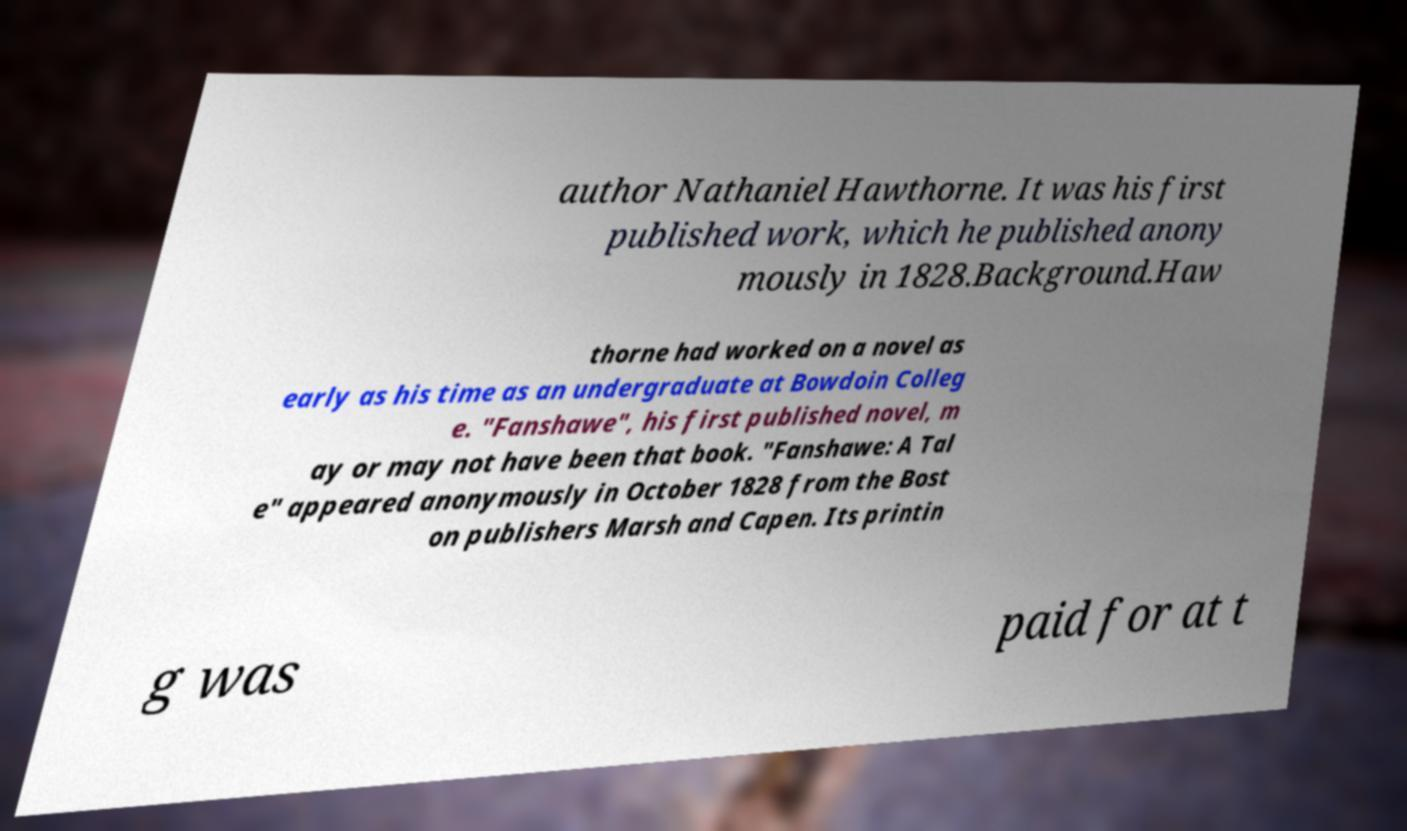Could you assist in decoding the text presented in this image and type it out clearly? author Nathaniel Hawthorne. It was his first published work, which he published anony mously in 1828.Background.Haw thorne had worked on a novel as early as his time as an undergraduate at Bowdoin Colleg e. "Fanshawe", his first published novel, m ay or may not have been that book. "Fanshawe: A Tal e" appeared anonymously in October 1828 from the Bost on publishers Marsh and Capen. Its printin g was paid for at t 